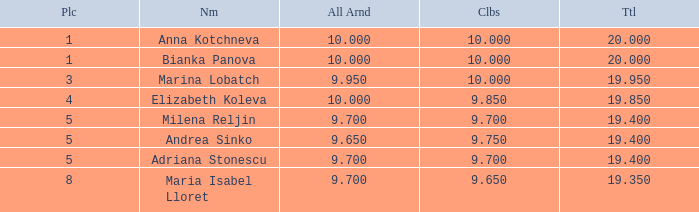What total has 10 as the clubs, with a place greater than 1? 19.95. 